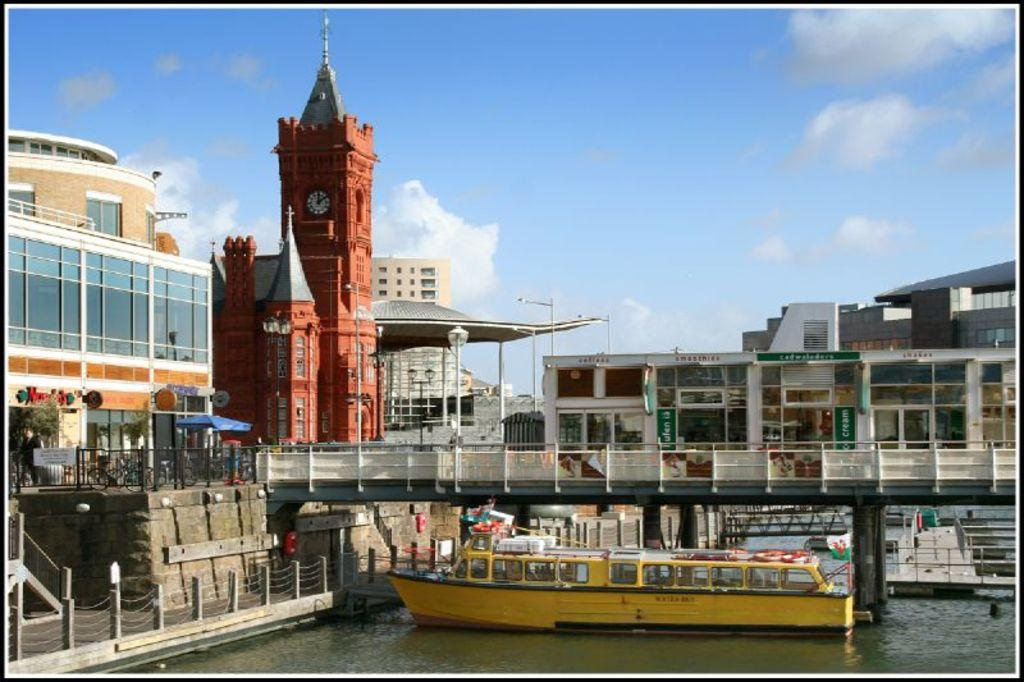What is located in the water in the image? There is a ship in the water in the image. What type of structure can be seen in the image? There is a building in the image. Can you describe a specific feature of the building? There is a clock tower in the image. What else can be seen in the image besides the ship and building? There are electric poles in the image. What is visible in the sky in the image? There are clouds in the sky in the image. What type of wilderness can be seen in the image? There is no wilderness present in the image; it features a ship in the water, a building, a clock tower, electric poles, and clouds in the sky. What phase of the moon is visible in the image? There is no moon visible in the image; it only shows clouds in the sky. 